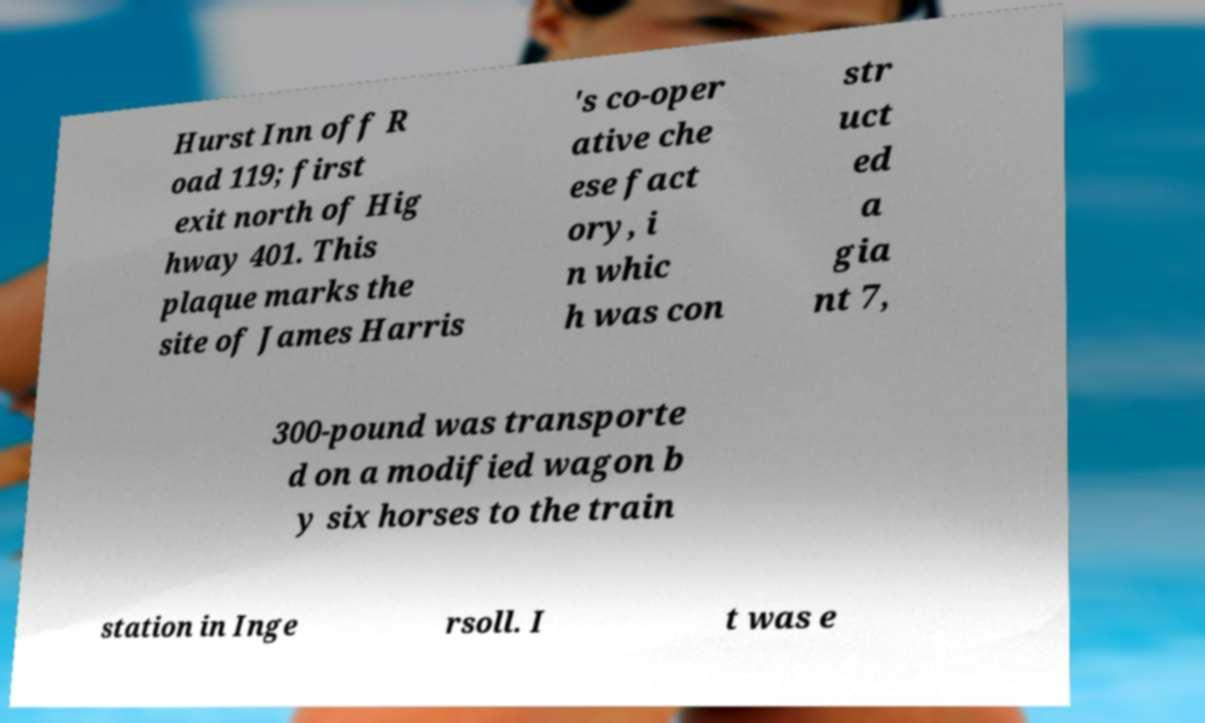For documentation purposes, I need the text within this image transcribed. Could you provide that? Hurst Inn off R oad 119; first exit north of Hig hway 401. This plaque marks the site of James Harris 's co-oper ative che ese fact ory, i n whic h was con str uct ed a gia nt 7, 300-pound was transporte d on a modified wagon b y six horses to the train station in Inge rsoll. I t was e 